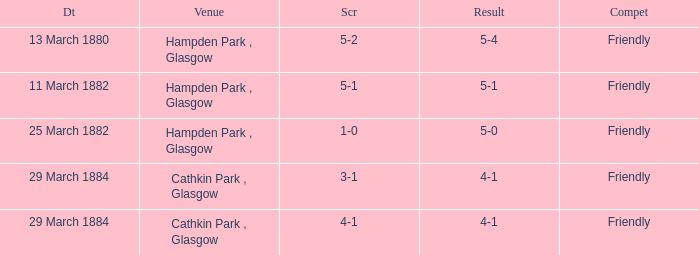Which item has a score of 5-1? 5-1. 